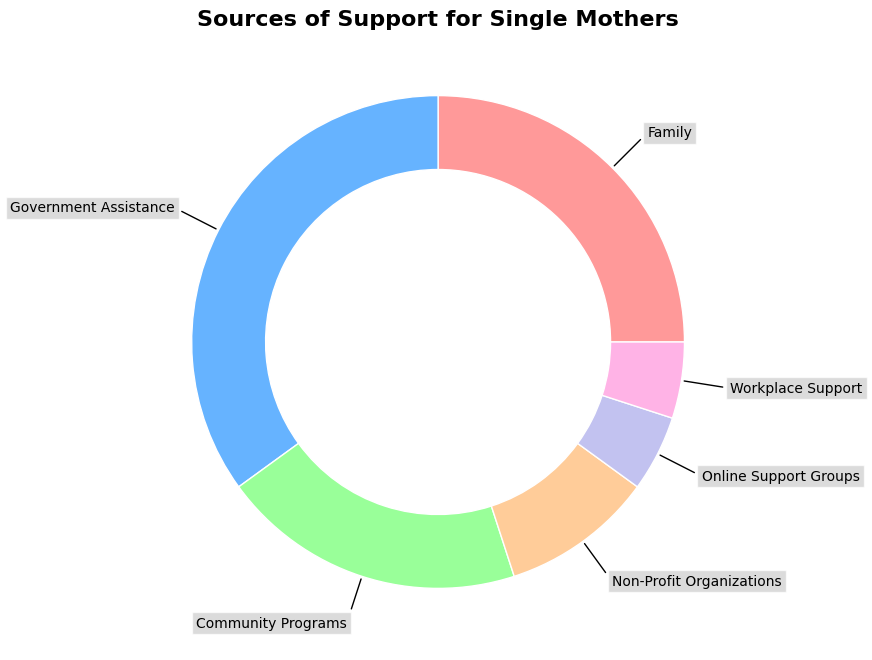What percentage of support comes from family and community programs combined? To find the combined percentage of support from family and community programs, add the respective percentages together: 25% (Family) + 20% (Community Programs) = 45%.
Answer: 45% Which source of support provides the highest percentage? By visually inspecting the largest section of the ring chart, the government assistance segment is the largest. The percentage is 35%.
Answer: Government Assistance Are non-profit organizations or online support groups a smaller source of support? Comparing the sizes of the segments for non-profit organizations (10%) and online support groups (5%), online support groups offer a smaller percentage of support.
Answer: Online Support Groups How does the support from workplace compare to that from community programs? The workplace support and community programs sections can be compared visually. Workplace support is 5%, while community programs provide 20%. Therefore, community programs provide more support.
Answer: Community Programs What is the combined percentage of the three smallest support sources? The three smallest sources of support are online support groups (5%), workplace support (5%), and non-profit organizations (10%). Adding these gives: 5% + 5% + 10% = 20%.
Answer: 20% How much larger is government assistance compared to family support? The government assistance section is 35%, while the family support section is 25%. Subtract the family percentage from the government percentage: 35% - 25% = 10%.
Answer: 10% Which sources of support together account for exactly half of the support? By looking at the segments, the family (25%) and community programs (20%) together account for 25% + 20% = 45%, which is less than half. Including non-profit organizations (10%) gives 45% + 10% = 55%, which is more than half. This combination does not fit. Now, consider government assistance (35%) and community programs (20%), which adds to 35% + 20% = 55% (also more than half). No combination fits exactly 50%.
Answer: None If community programs increased its support by 5%, what would its new percentage be? The current support from community programs is 20%. Adding 5% gives: 20% + 5% = 25%.
Answer: 25% 